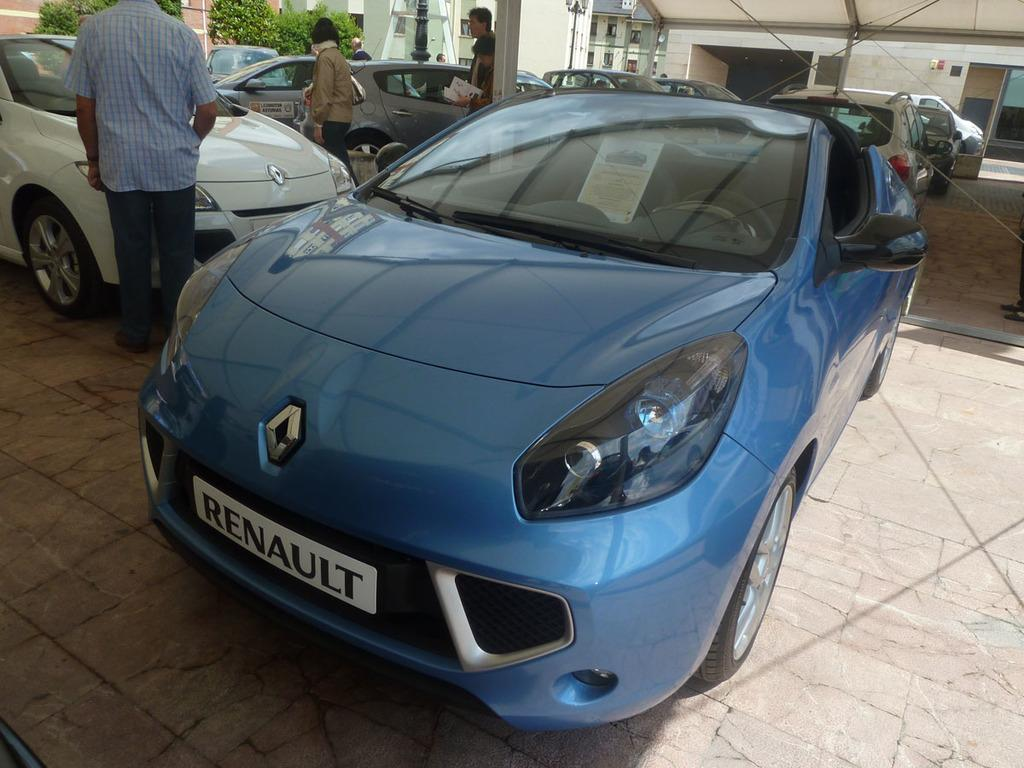What can be seen on the path in the image? There are vehicles and people visible on the path in the image. What is visible in the background of the image? There are plants and buildings in the background of the image. What type of calculator can be seen on the path in the image? There is no calculator present in the image; it features vehicles and people on the path. What color is the silver thing visible in the image? There is no silver thing present in the image. 